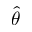<formula> <loc_0><loc_0><loc_500><loc_500>\hat { \theta }</formula> 